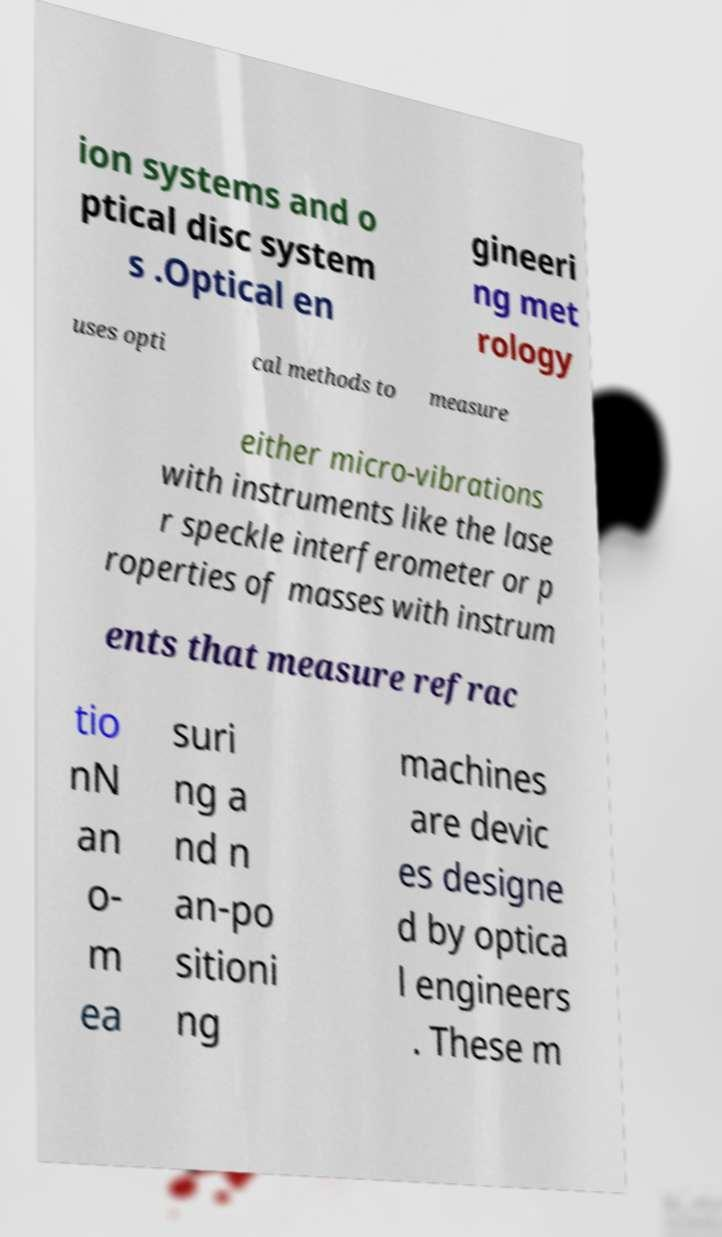Could you assist in decoding the text presented in this image and type it out clearly? ion systems and o ptical disc system s .Optical en gineeri ng met rology uses opti cal methods to measure either micro-vibrations with instruments like the lase r speckle interferometer or p roperties of masses with instrum ents that measure refrac tio nN an o- m ea suri ng a nd n an-po sitioni ng machines are devic es designe d by optica l engineers . These m 